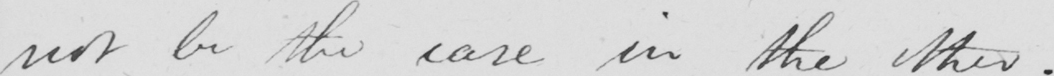Can you tell me what this handwritten text says? not be the case in the other . 